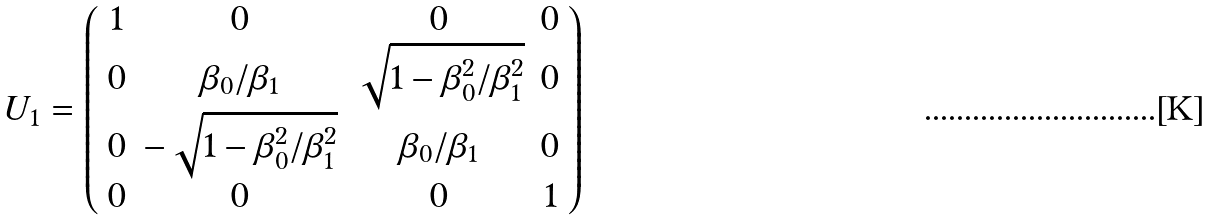Convert formula to latex. <formula><loc_0><loc_0><loc_500><loc_500>U _ { 1 } = \left ( \begin{array} { c c c c } 1 & 0 & 0 & 0 \\ 0 & \beta _ { 0 } / \beta _ { 1 } & \sqrt { 1 - \beta _ { 0 } ^ { 2 } / \beta _ { 1 } ^ { 2 } } & 0 \\ 0 & - \sqrt { 1 - \beta _ { 0 } ^ { 2 } / \beta _ { 1 } ^ { 2 } } & \beta _ { 0 } / \beta _ { 1 } & 0 \\ 0 & 0 & 0 & 1 \\ \end{array} \right )</formula> 